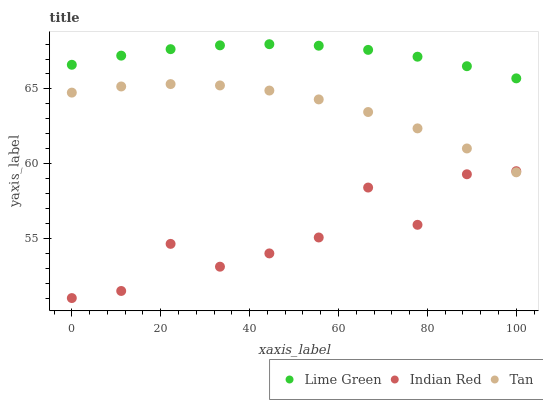Does Indian Red have the minimum area under the curve?
Answer yes or no. Yes. Does Lime Green have the maximum area under the curve?
Answer yes or no. Yes. Does Lime Green have the minimum area under the curve?
Answer yes or no. No. Does Indian Red have the maximum area under the curve?
Answer yes or no. No. Is Lime Green the smoothest?
Answer yes or no. Yes. Is Indian Red the roughest?
Answer yes or no. Yes. Is Indian Red the smoothest?
Answer yes or no. No. Is Lime Green the roughest?
Answer yes or no. No. Does Indian Red have the lowest value?
Answer yes or no. Yes. Does Lime Green have the lowest value?
Answer yes or no. No. Does Lime Green have the highest value?
Answer yes or no. Yes. Does Indian Red have the highest value?
Answer yes or no. No. Is Indian Red less than Lime Green?
Answer yes or no. Yes. Is Lime Green greater than Tan?
Answer yes or no. Yes. Does Indian Red intersect Tan?
Answer yes or no. Yes. Is Indian Red less than Tan?
Answer yes or no. No. Is Indian Red greater than Tan?
Answer yes or no. No. Does Indian Red intersect Lime Green?
Answer yes or no. No. 